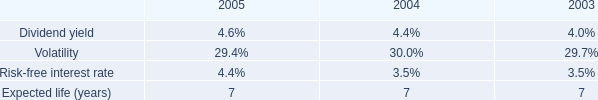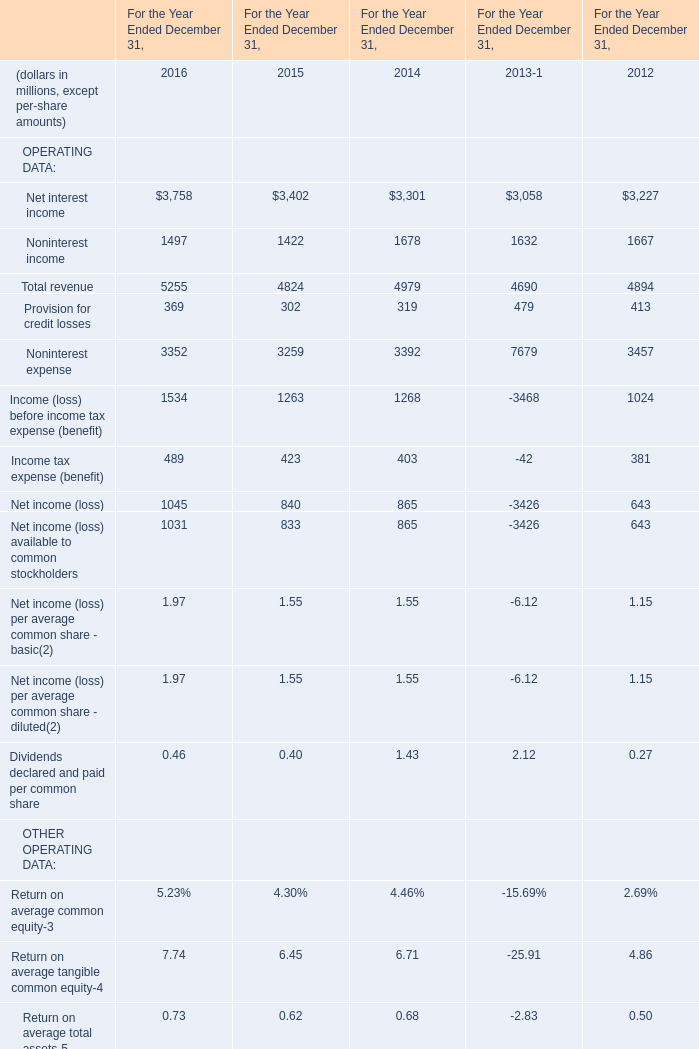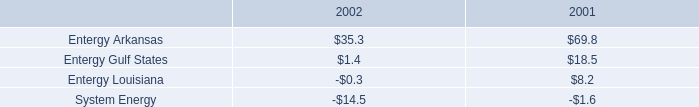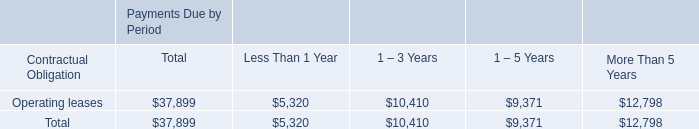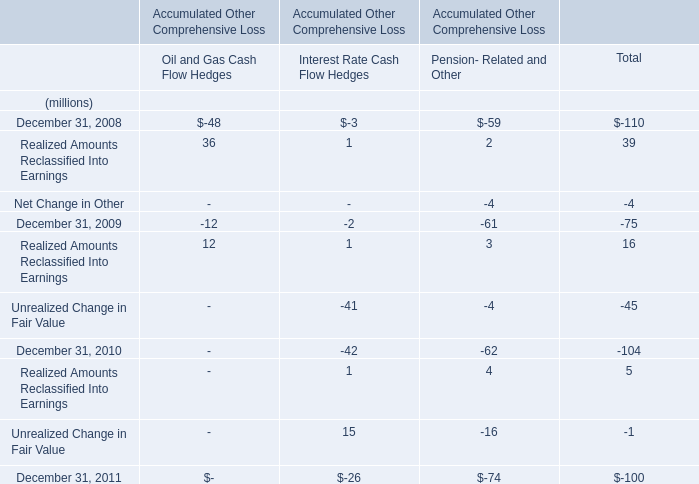Between 2008,2009 and 2010,which year is Realized Amounts Reclassified Into Earnings for Pension- Related and Other in terms of Accumulated Other Comprehensive Loss worth 4 million? 
Answer: 2010. 